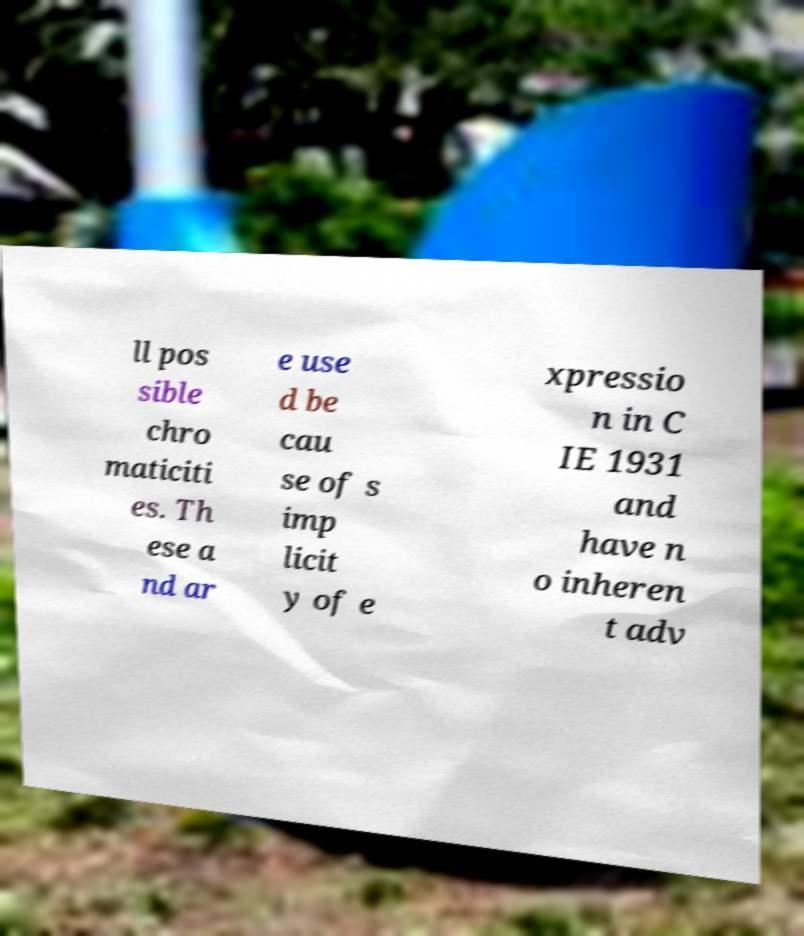There's text embedded in this image that I need extracted. Can you transcribe it verbatim? ll pos sible chro maticiti es. Th ese a nd ar e use d be cau se of s imp licit y of e xpressio n in C IE 1931 and have n o inheren t adv 